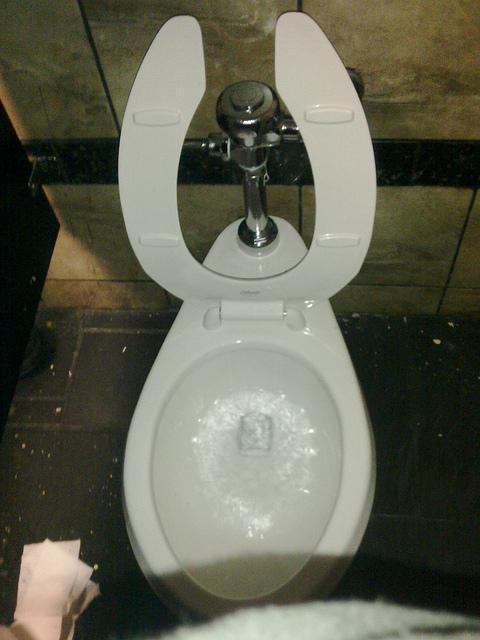How many lids are down?
Give a very brief answer. 0. 